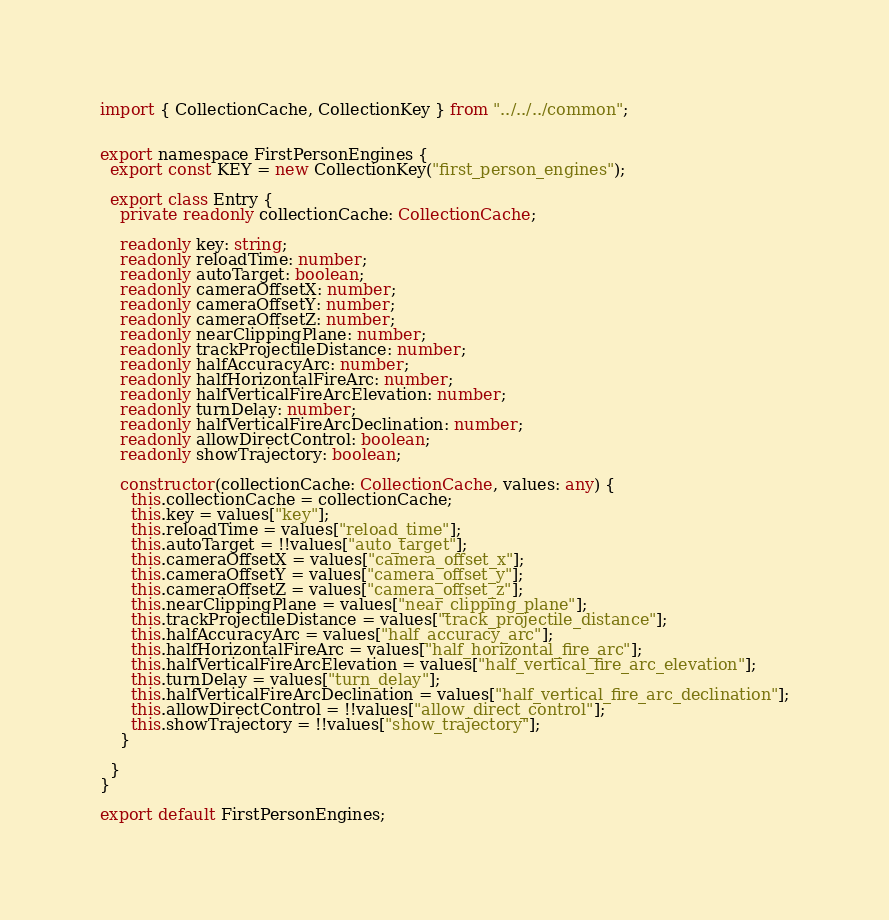Convert code to text. <code><loc_0><loc_0><loc_500><loc_500><_TypeScript_>
import { CollectionCache, CollectionKey } from "../../../common";


export namespace FirstPersonEngines {
  export const KEY = new CollectionKey("first_person_engines");

  export class Entry {
    private readonly collectionCache: CollectionCache;

    readonly key: string;
    readonly reloadTime: number;
    readonly autoTarget: boolean;
    readonly cameraOffsetX: number;
    readonly cameraOffsetY: number;
    readonly cameraOffsetZ: number;
    readonly nearClippingPlane: number;
    readonly trackProjectileDistance: number;
    readonly halfAccuracyArc: number;
    readonly halfHorizontalFireArc: number;
    readonly halfVerticalFireArcElevation: number;
    readonly turnDelay: number;
    readonly halfVerticalFireArcDeclination: number;
    readonly allowDirectControl: boolean;
    readonly showTrajectory: boolean;

    constructor(collectionCache: CollectionCache, values: any) {
      this.collectionCache = collectionCache;
      this.key = values["key"];
      this.reloadTime = values["reload_time"];
      this.autoTarget = !!values["auto_target"];
      this.cameraOffsetX = values["camera_offset_x"];
      this.cameraOffsetY = values["camera_offset_y"];
      this.cameraOffsetZ = values["camera_offset_z"];
      this.nearClippingPlane = values["near_clipping_plane"];
      this.trackProjectileDistance = values["track_projectile_distance"];
      this.halfAccuracyArc = values["half_accuracy_arc"];
      this.halfHorizontalFireArc = values["half_horizontal_fire_arc"];
      this.halfVerticalFireArcElevation = values["half_vertical_fire_arc_elevation"];
      this.turnDelay = values["turn_delay"];
      this.halfVerticalFireArcDeclination = values["half_vertical_fire_arc_declination"];
      this.allowDirectControl = !!values["allow_direct_control"];
      this.showTrajectory = !!values["show_trajectory"];
    }
    
  }
}

export default FirstPersonEngines;
</code> 